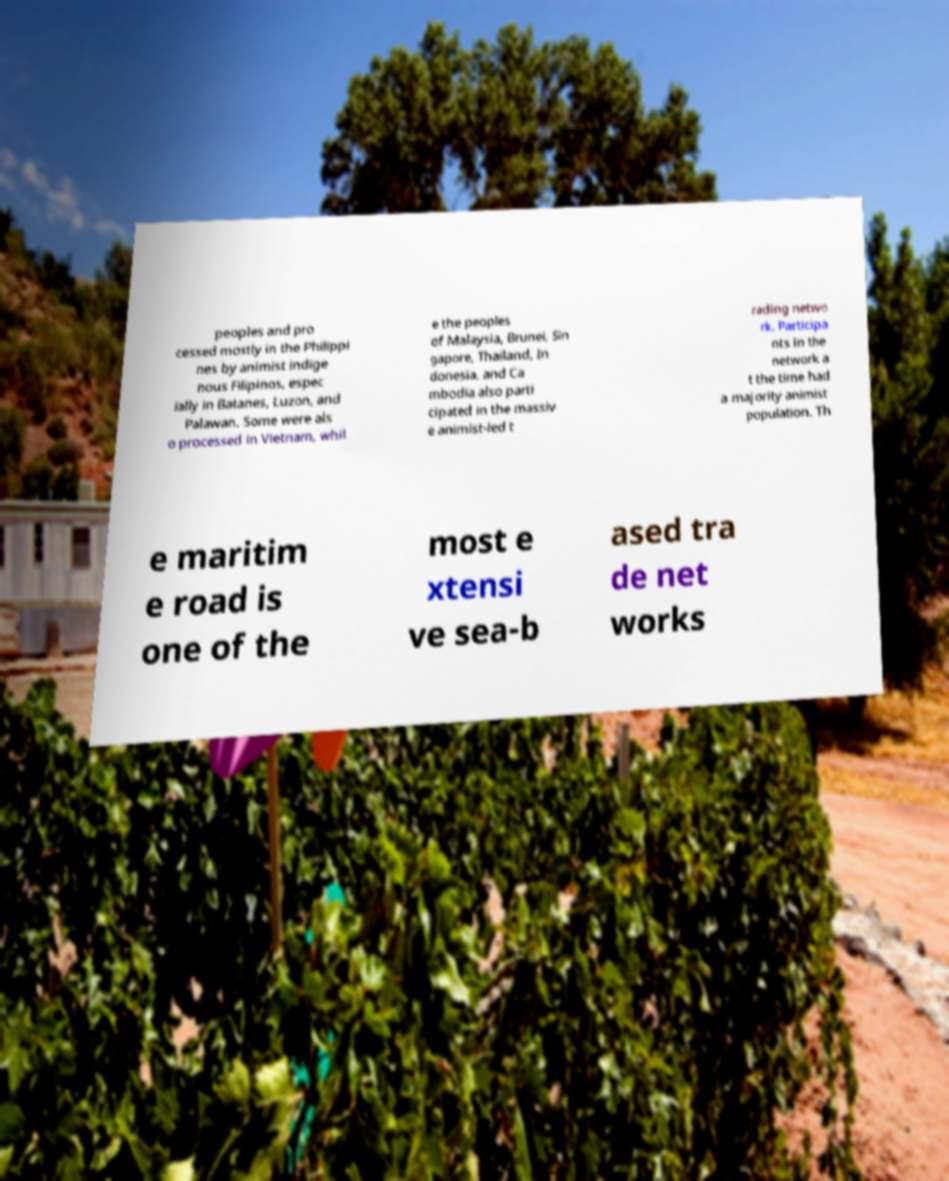Could you assist in decoding the text presented in this image and type it out clearly? peoples and pro cessed mostly in the Philippi nes by animist indige nous Filipinos, espec ially in Batanes, Luzon, and Palawan. Some were als o processed in Vietnam, whil e the peoples of Malaysia, Brunei, Sin gapore, Thailand, In donesia, and Ca mbodia also parti cipated in the massiv e animist-led t rading netwo rk. Participa nts in the network a t the time had a majority animist population. Th e maritim e road is one of the most e xtensi ve sea-b ased tra de net works 